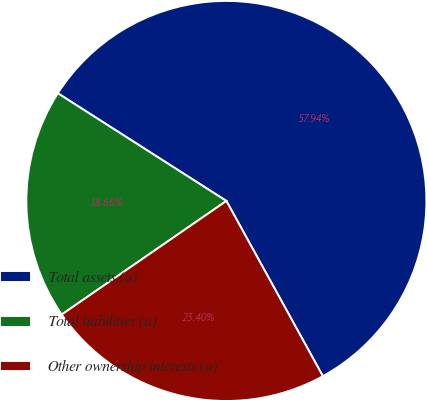Convert chart to OTSL. <chart><loc_0><loc_0><loc_500><loc_500><pie_chart><fcel>Total assets (a)<fcel>Total liabilities (a)<fcel>Other ownership interests (a)<nl><fcel>57.94%<fcel>18.66%<fcel>23.4%<nl></chart> 